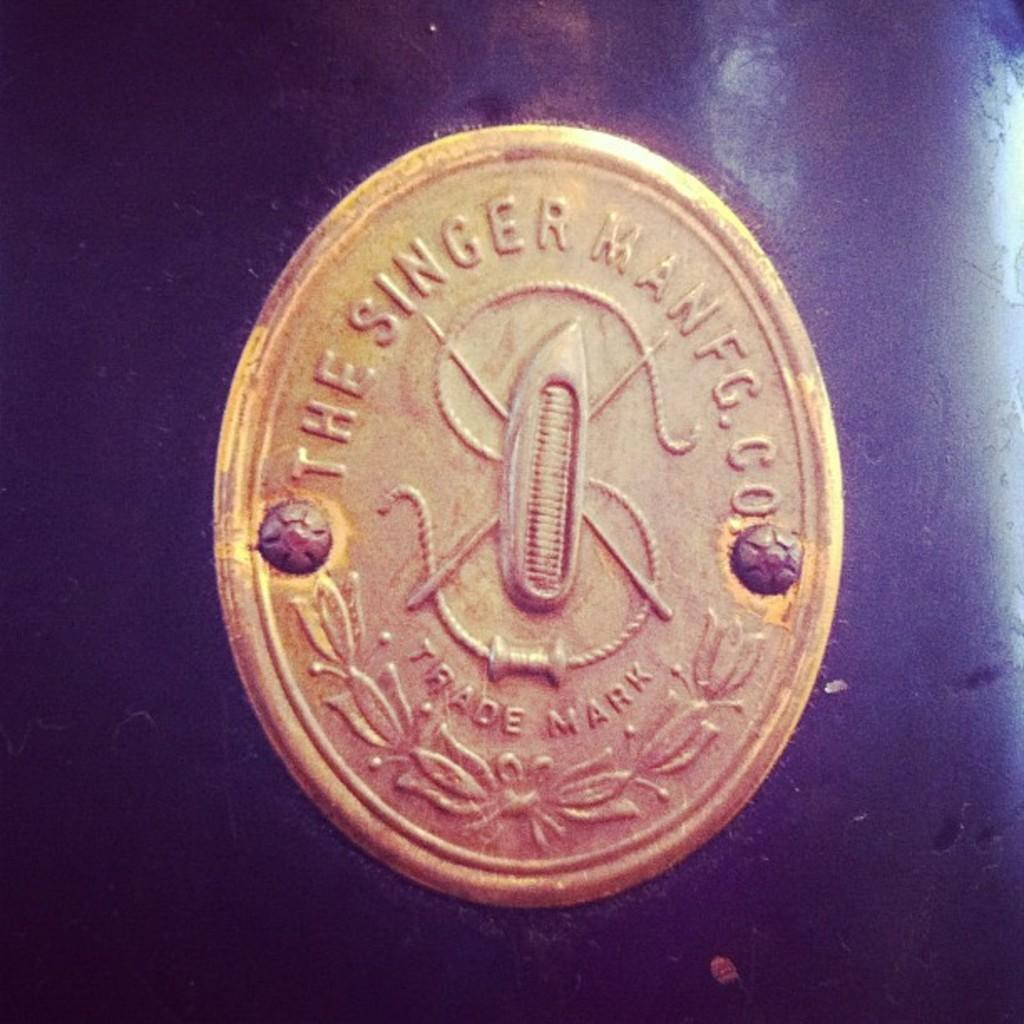<image>
Describe the image concisely. a golden coin that says 'the singer man fg.co' 